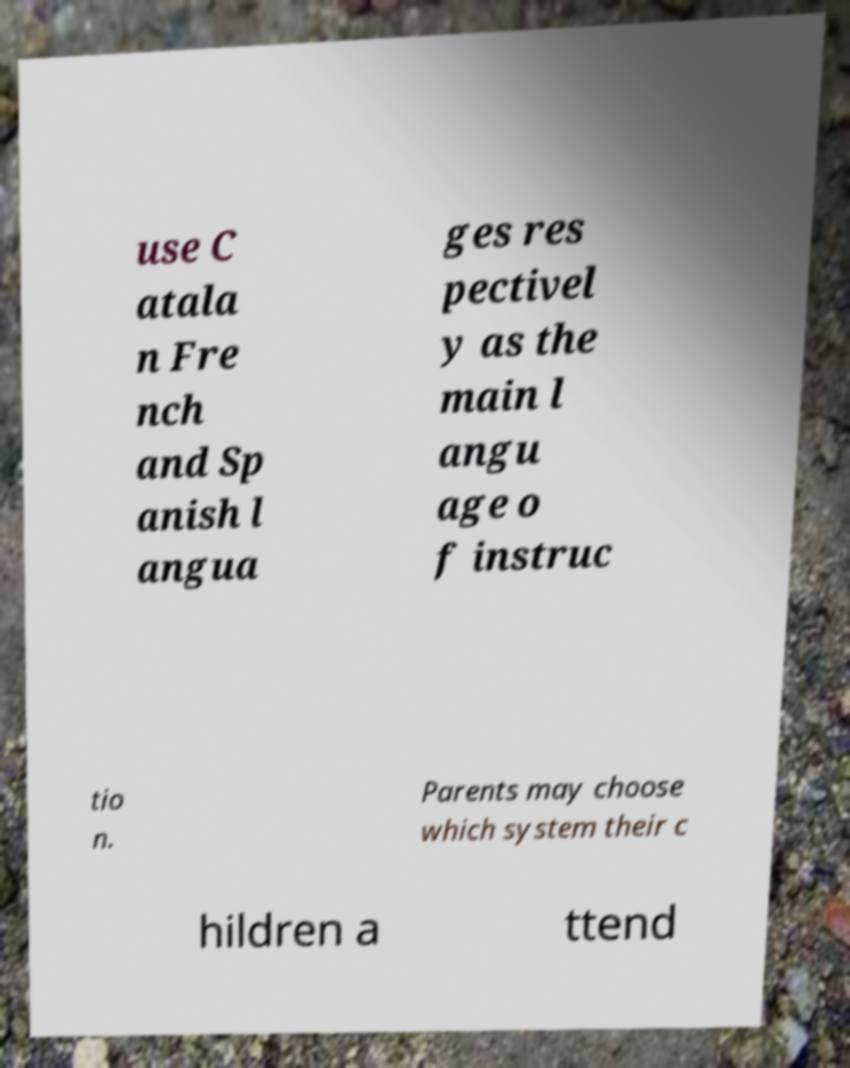For documentation purposes, I need the text within this image transcribed. Could you provide that? use C atala n Fre nch and Sp anish l angua ges res pectivel y as the main l angu age o f instruc tio n. Parents may choose which system their c hildren a ttend 